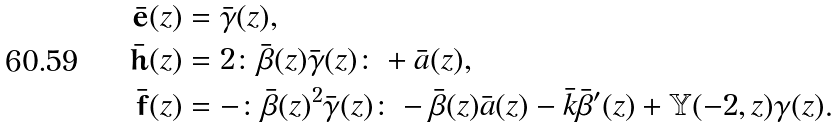<formula> <loc_0><loc_0><loc_500><loc_500>\bar { \mathbf e } ( z ) & = \bar { \gamma } ( z ) , \\ \bar { \mathbf h } ( z ) & = 2 \colon \bar { \beta } ( z ) \bar { \gamma } ( z ) \colon + \bar { a } ( z ) , \\ \bar { \mathbf f } ( z ) & = - \colon \bar { \beta } ( z ) ^ { 2 } \bar { \gamma } ( z ) \colon - \bar { \beta } ( z ) \bar { a } ( z ) - \bar { k } \bar { \beta } ^ { \prime } ( z ) + \mathbb { Y } ( - 2 , z ) \gamma ( z ) .</formula> 